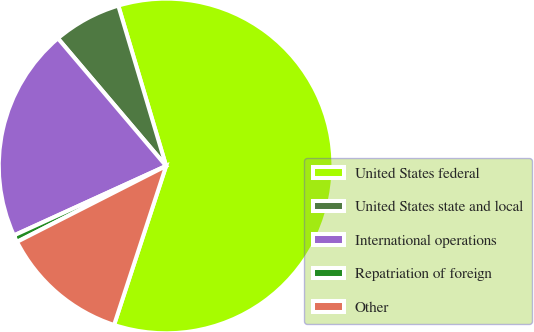<chart> <loc_0><loc_0><loc_500><loc_500><pie_chart><fcel>United States federal<fcel>United States state and local<fcel>International operations<fcel>Repatriation of foreign<fcel>Other<nl><fcel>59.65%<fcel>6.58%<fcel>20.62%<fcel>0.68%<fcel>12.47%<nl></chart> 